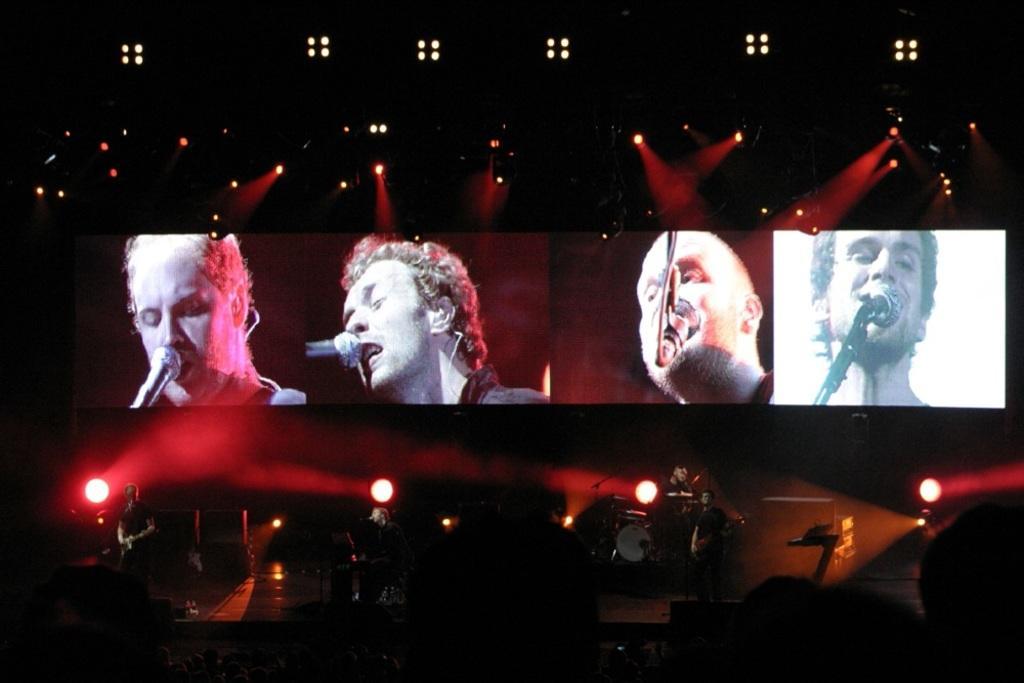Please provide a concise description of this image. In the background of the image there is a screen in which there are people sing songs holding mic. At the bottom of the image there are people playing musical instruments. At the top of the image there are lights. At the bottom of the image there are persons heads. 